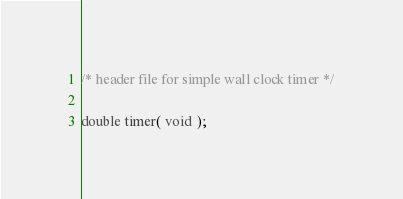Convert code to text. <code><loc_0><loc_0><loc_500><loc_500><_C_>/* header file for simple wall clock timer */

double timer( void );
</code> 